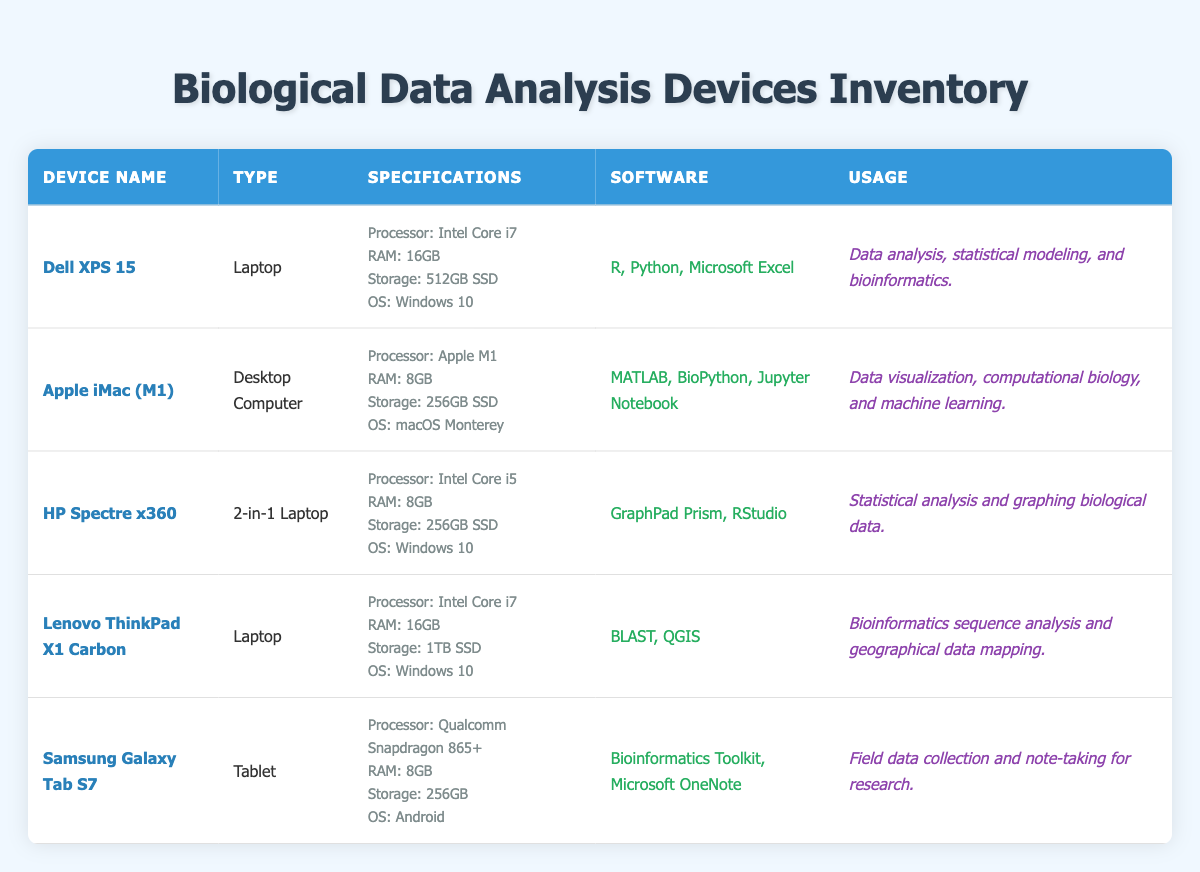What is the type of the Dell XPS 15? The Dell XPS 15 is categorized as a Laptop based on the "Type" column in the table.
Answer: Laptop Which software is used on the Apple iMac (M1)? The Apple iMac (M1) has three software programs listed: MATLAB, BioPython, and Jupyter Notebook, found under the "Software" column.
Answer: MATLAB, BioPython, Jupyter Notebook How much RAM does the Lenovo ThinkPad X1 Carbon have? The Lenovo ThinkPad X1 Carbon has 16GB of RAM, which is detailed in the "Specifications" section in the table.
Answer: 16GB Is the HP Spectre x360 used for data analysis? Yes, the HP Spectre x360 is used for statistical analysis and graphing biological data, as indicated in its "Usage" description.
Answer: Yes Which devices have an Intel Core i7 processor? The Dell XPS 15 and the Lenovo ThinkPad X1 Carbon both have an Intel Core i7 processor, as seen in the "Specifications" section of their respective rows.
Answer: Dell XPS 15, Lenovo ThinkPad X1 Carbon What is the total SSD storage of the Dell XPS 15 and Lenovo ThinkPad X1 Carbon combined? The Dell XPS 15 has a storage of 512GB SSD and the Lenovo ThinkPad X1 Carbon has 1TB SSD. Converting 1TB to GB gives 1024GB. Therefore, adding them together: 512GB + 1024GB = 1536GB.
Answer: 1536GB Does the Samsung Galaxy Tab S7 support the use of Microsoft OneNote? Yes, the Samsung Galaxy Tab S7 includes Microsoft OneNote in its software list, confirming its support for this application.
Answer: Yes Which device is best suited for field data collection? The Samsung Galaxy Tab S7 is indicated as suitable for field data collection in the "Usage" column, as it is made for note-taking and data collection for research during fieldwork.
Answer: Samsung Galaxy Tab S7 What is the average RAM of the devices listed in the inventory? The RAMs listed for each device are 16GB, 8GB, 8GB, 16GB, and 8GB. To find the average: (16 + 8 + 8 + 16 + 8) / 5 = 56 / 5 = 11.2GB.
Answer: 11.2GB 